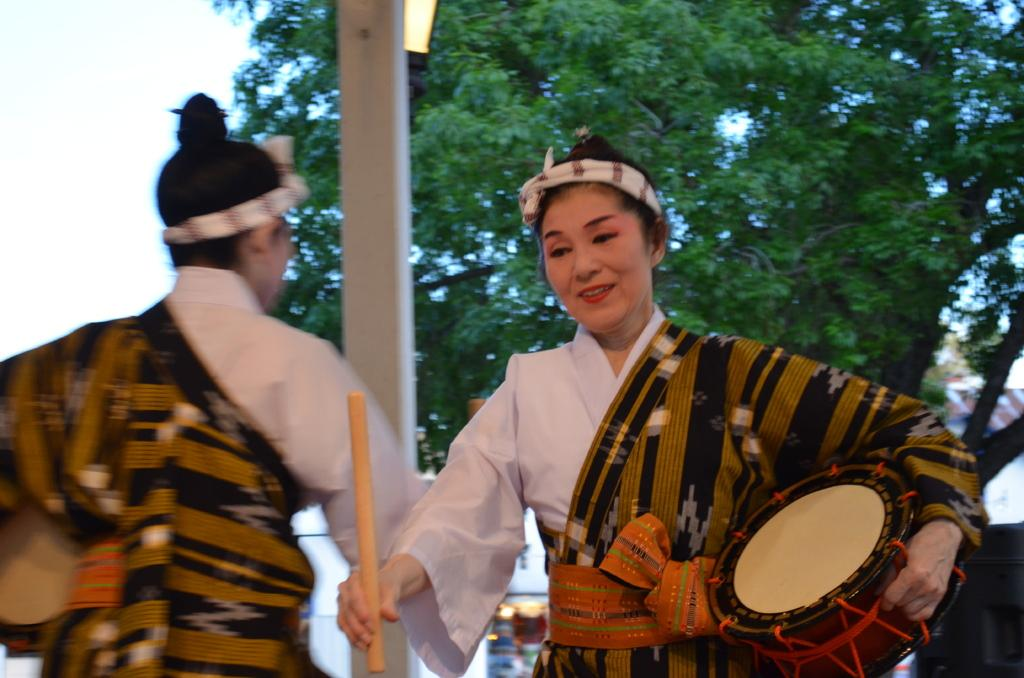How many people are in the image? There are two persons in the image. What is the person on the right side holding? The person on the right side is holding a stick and a drum. What can be seen in the background of the image? There is a tree visible in the background of the image. What type of jelly can be seen dripping from the tree in the image? There is no jelly present in the image, and the tree is not depicted as dripping anything. 